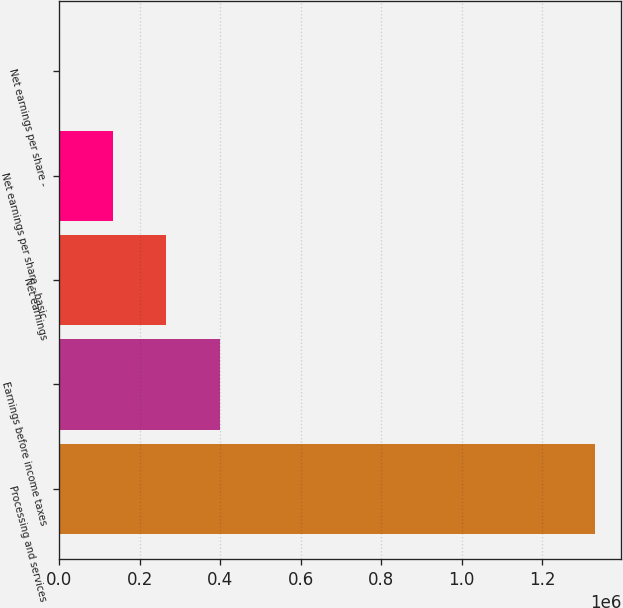Convert chart. <chart><loc_0><loc_0><loc_500><loc_500><bar_chart><fcel>Processing and services<fcel>Earnings before income taxes<fcel>Net earnings<fcel>Net earnings per share - basic<fcel>Net earnings per share -<nl><fcel>1.33041e+06<fcel>399125<fcel>266083<fcel>133042<fcel>0.55<nl></chart> 